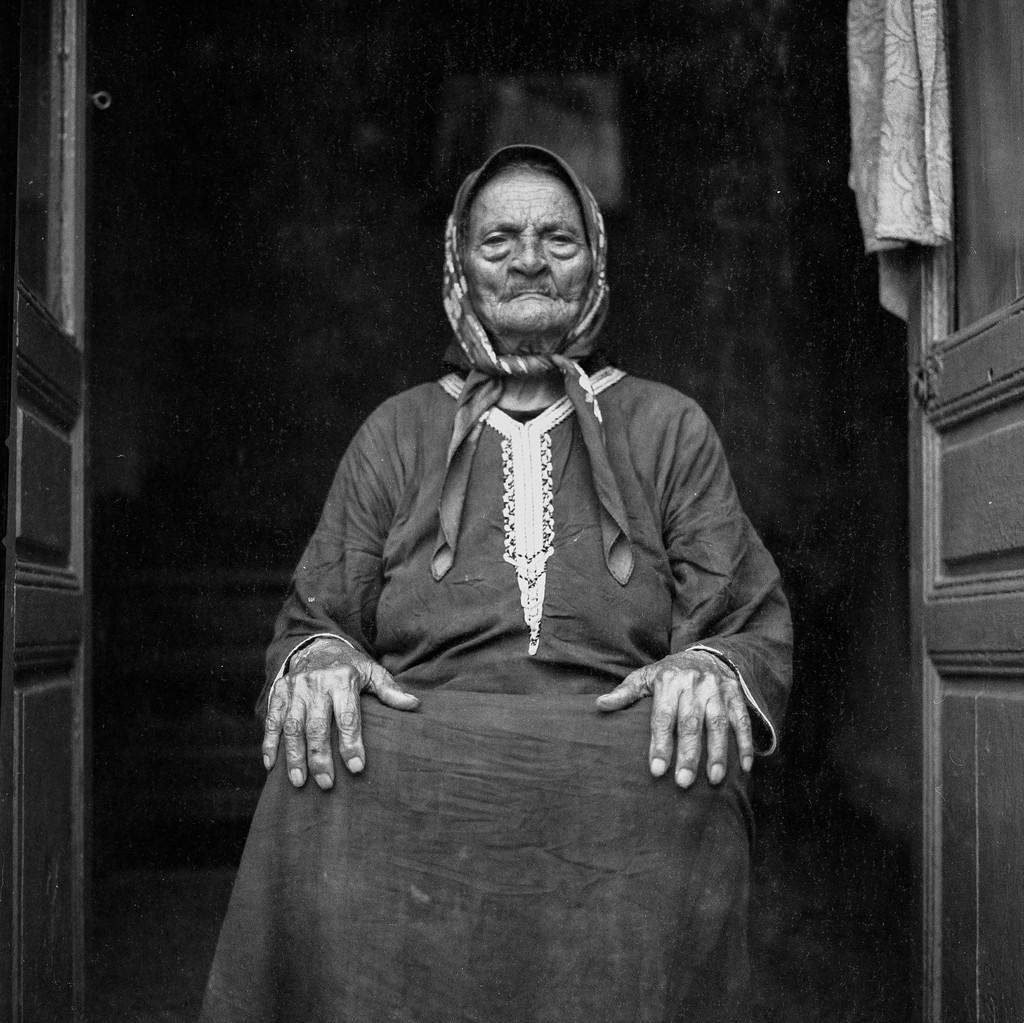What is the person in the image doing? There is a person sitting in the image. What can be seen on both sides of the image? There are doors on both sides of the image. What is located on the right side of the image? There is a cloth on the right side of the image. How would you describe the overall lighting in the image? The background of the image is dark. How does the writer tie a knot in the image? There is no writer or knot present in the image. 